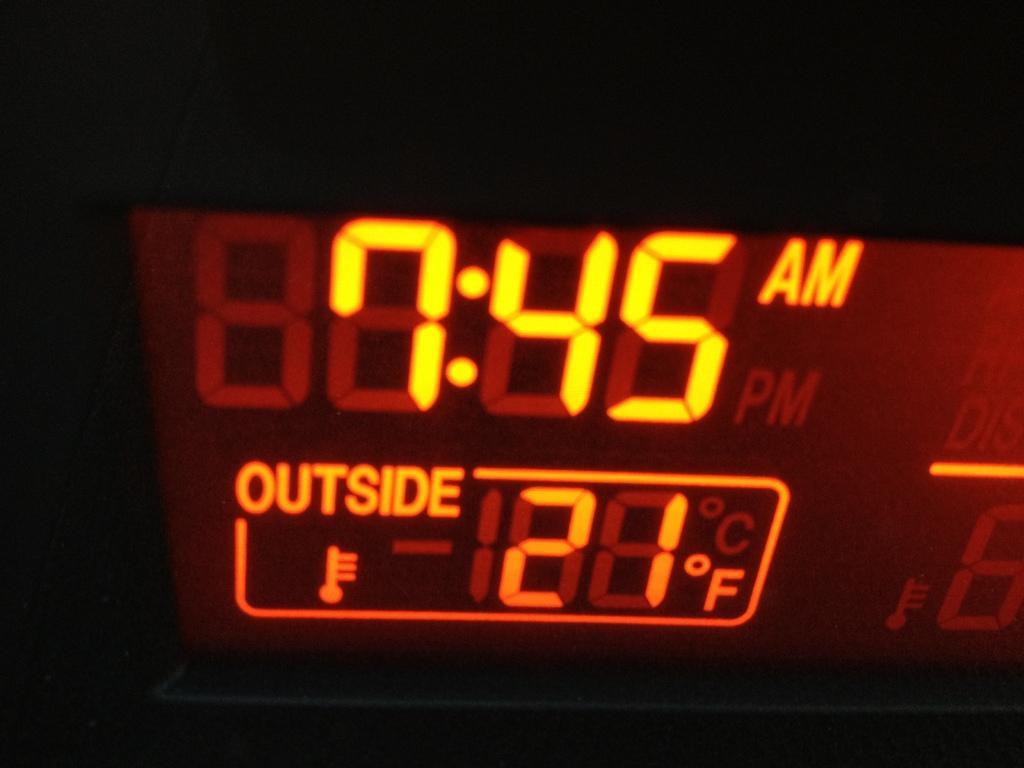Can you describe this image briefly? This image looks like an inside view of a vehicle taken during night. 